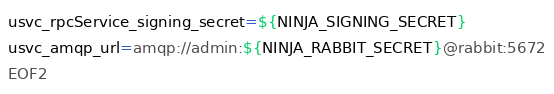Convert code to text. <code><loc_0><loc_0><loc_500><loc_500><_Bash_>usvc_rpcService_signing_secret=${NINJA_SIGNING_SECRET}
usvc_amqp_url=amqp://admin:${NINJA_RABBIT_SECRET}@rabbit:5672
EOF2
</code> 